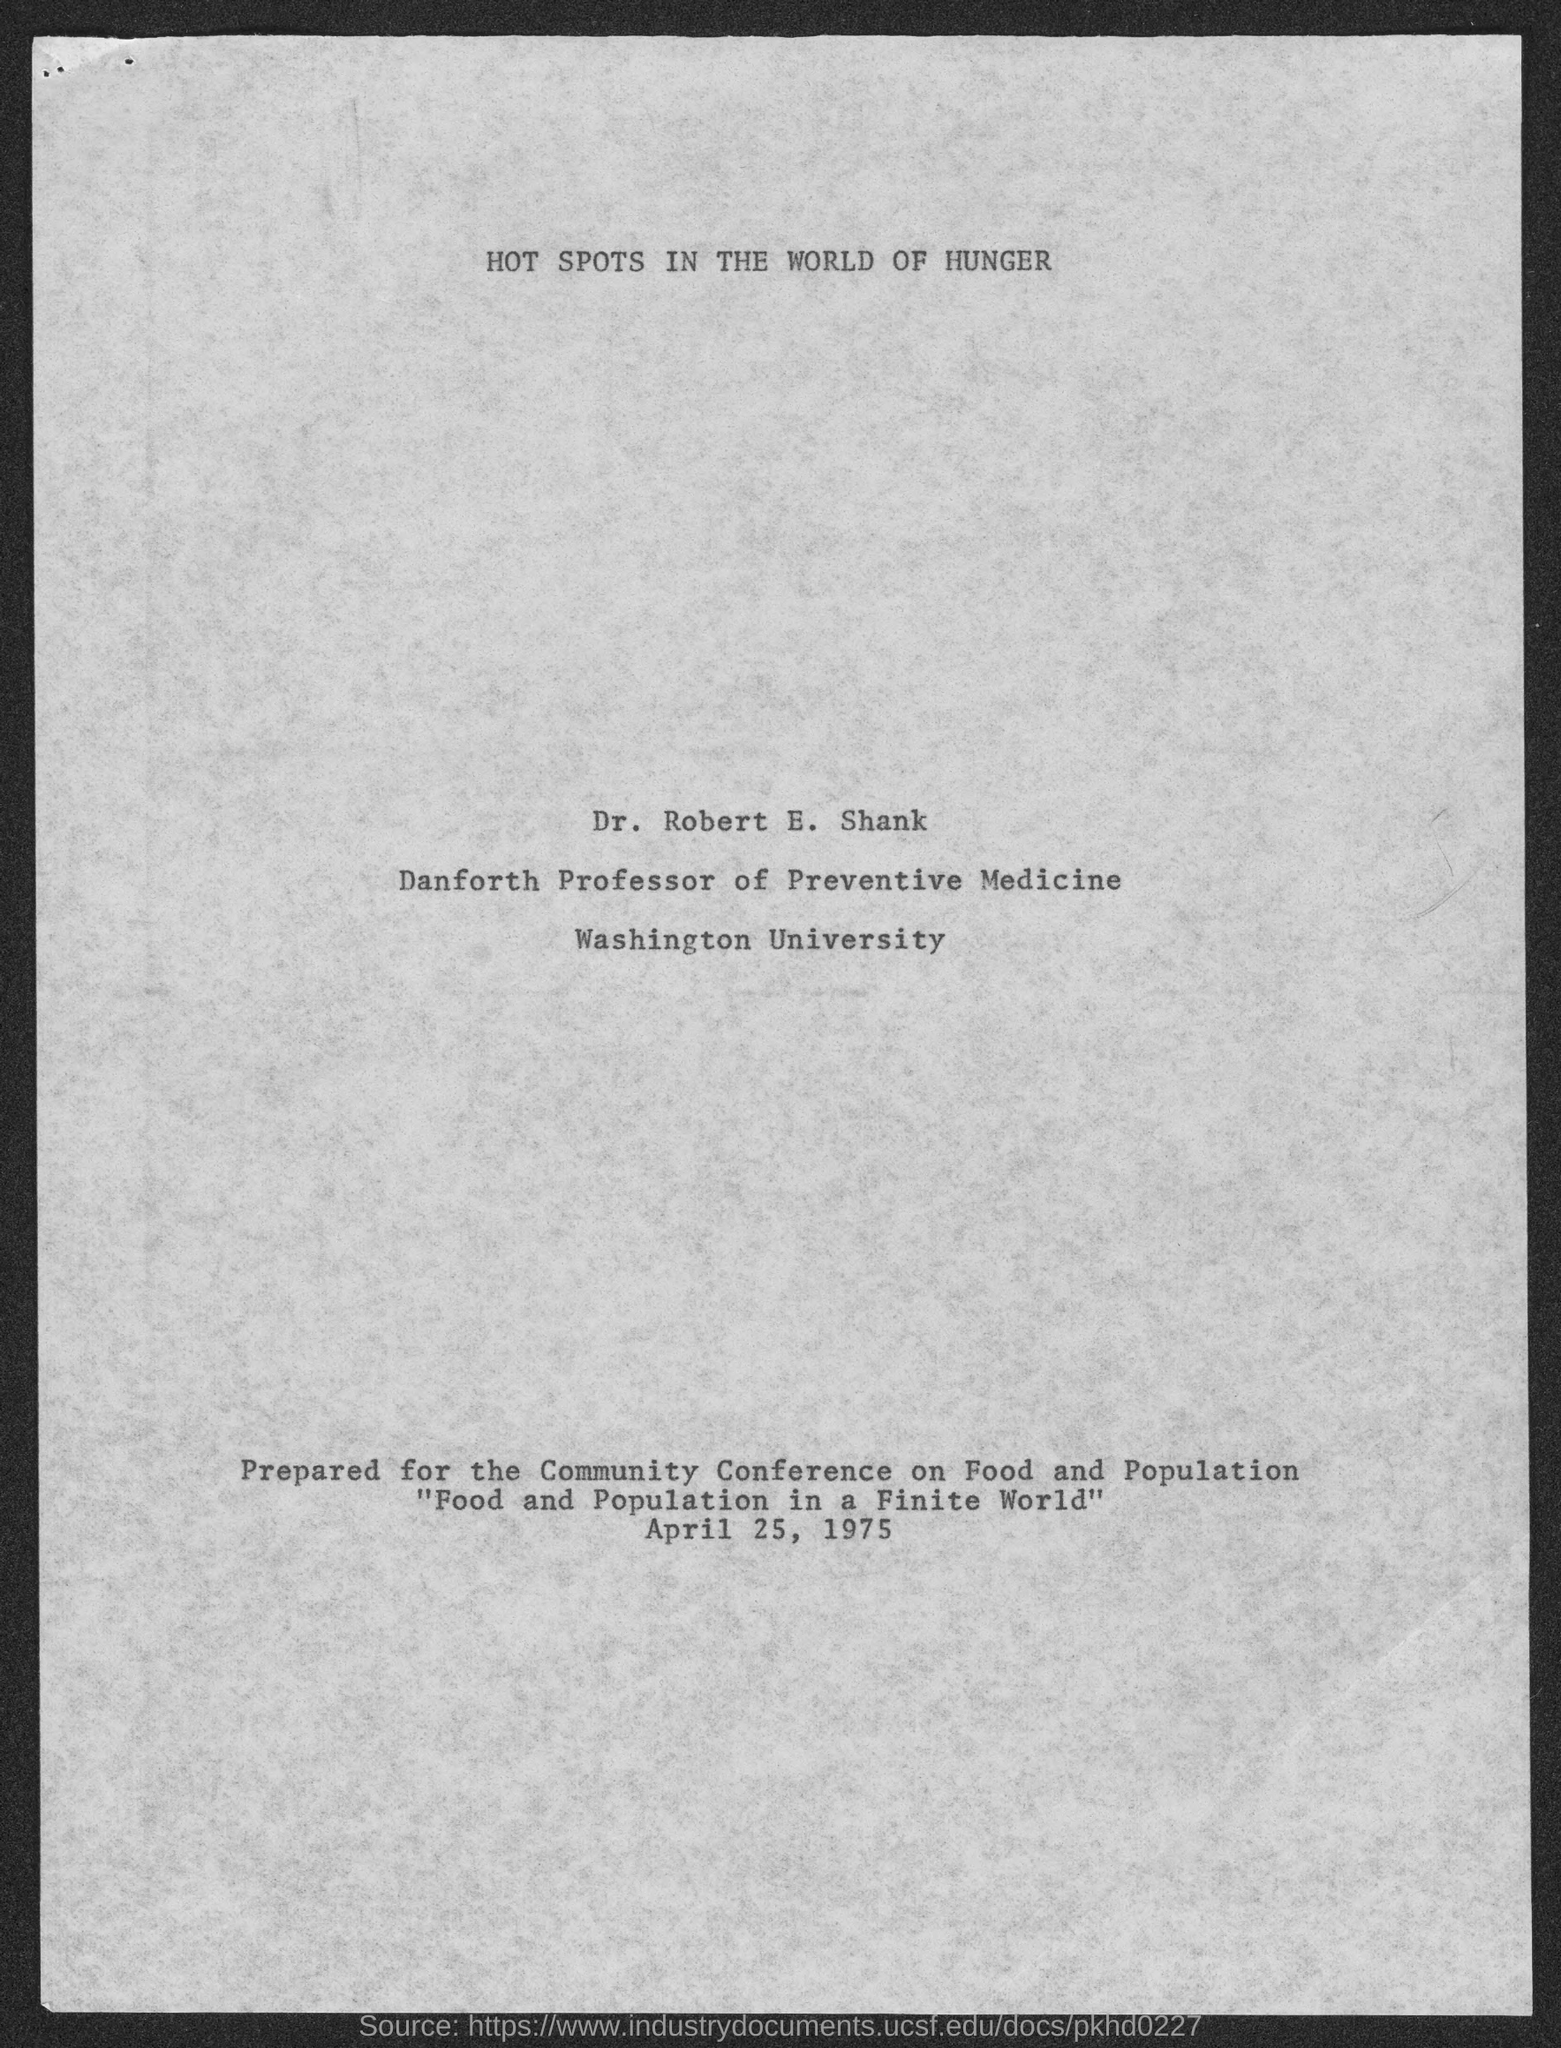What is the position of dr. robert e. shank ?
Your answer should be compact. Danforth Professor of Preventive Medicine. To which university does Dr. Robert E. Shank belong ?
Provide a succinct answer. Washington University. 